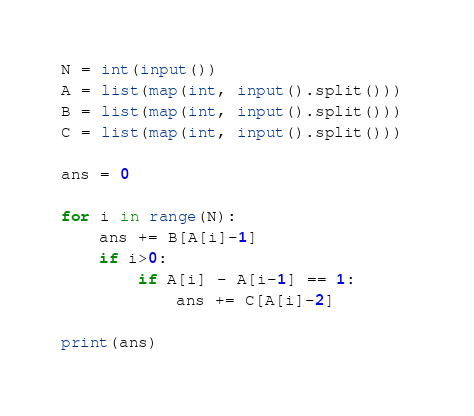Convert code to text. <code><loc_0><loc_0><loc_500><loc_500><_Python_>N = int(input())
A = list(map(int, input().split())) 
B = list(map(int, input().split())) 
C = list(map(int, input().split())) 

ans = 0

for i in range(N):
    ans += B[A[i]-1]
    if i>0:
        if A[i] - A[i-1] == 1:
            ans += C[A[i]-2]

print(ans)</code> 